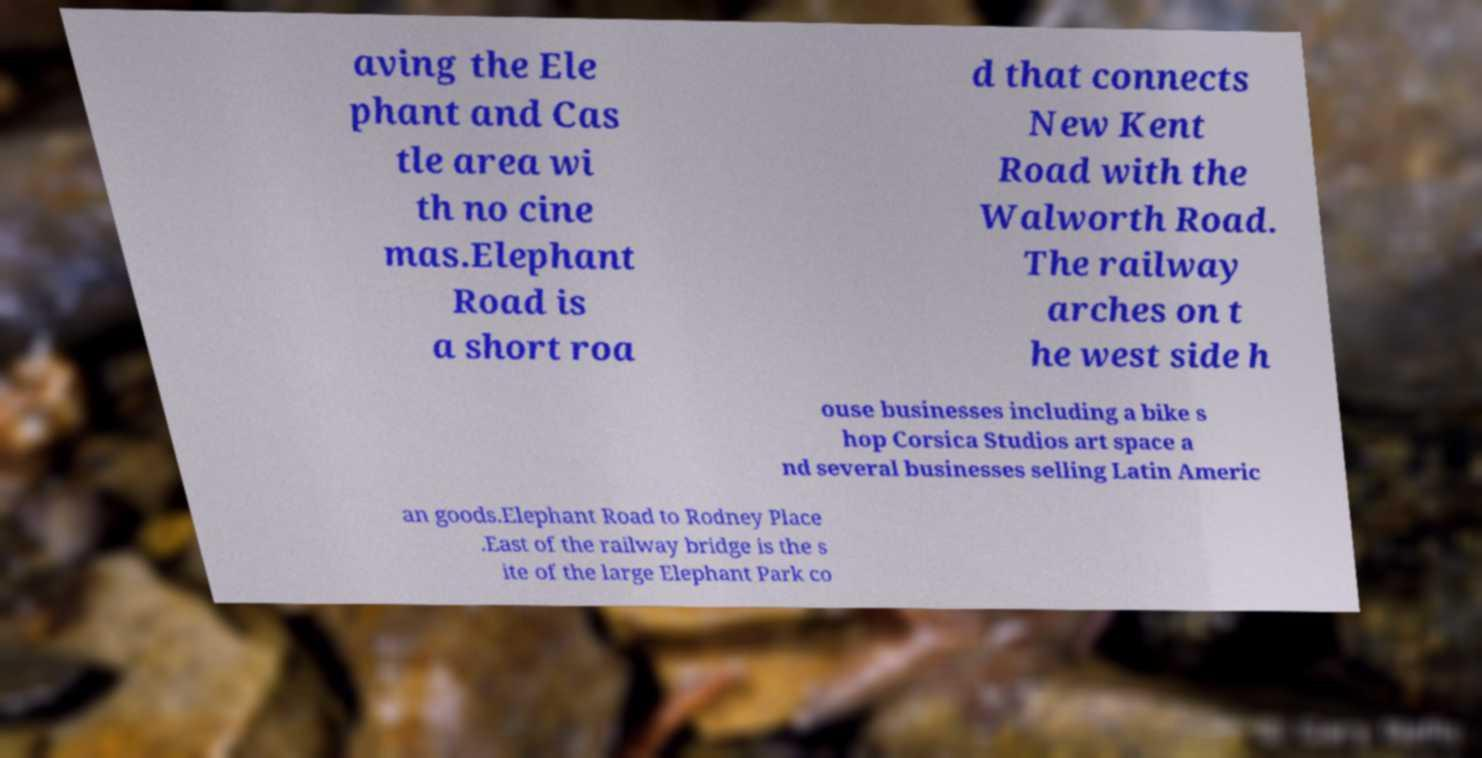Please identify and transcribe the text found in this image. aving the Ele phant and Cas tle area wi th no cine mas.Elephant Road is a short roa d that connects New Kent Road with the Walworth Road. The railway arches on t he west side h ouse businesses including a bike s hop Corsica Studios art space a nd several businesses selling Latin Americ an goods.Elephant Road to Rodney Place .East of the railway bridge is the s ite of the large Elephant Park co 